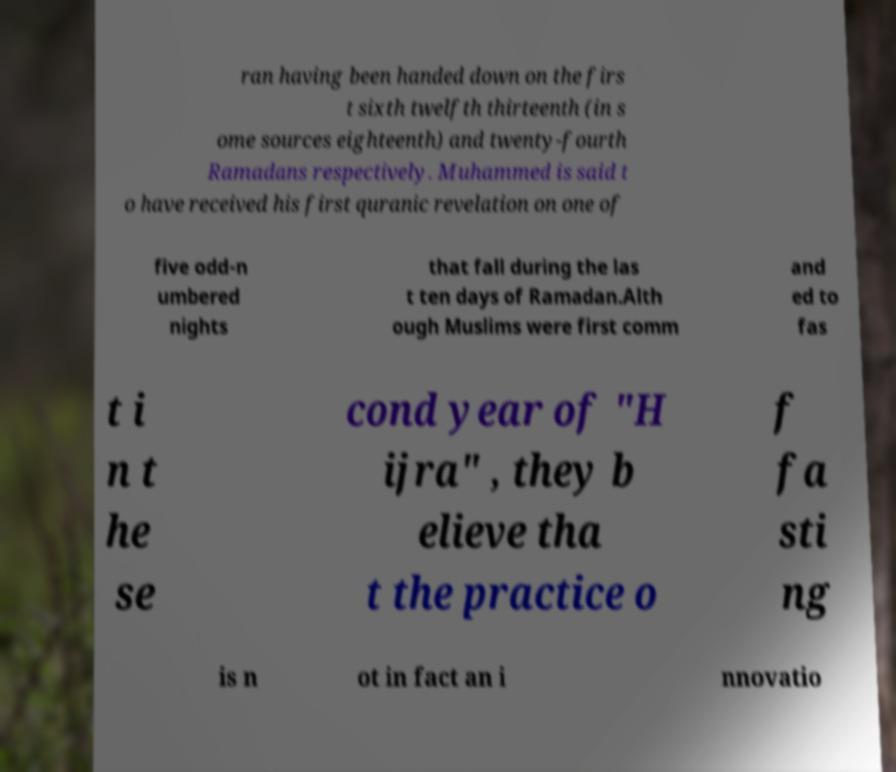What messages or text are displayed in this image? I need them in a readable, typed format. ran having been handed down on the firs t sixth twelfth thirteenth (in s ome sources eighteenth) and twenty-fourth Ramadans respectively. Muhammed is said t o have received his first quranic revelation on one of five odd-n umbered nights that fall during the las t ten days of Ramadan.Alth ough Muslims were first comm and ed to fas t i n t he se cond year of "H ijra" , they b elieve tha t the practice o f fa sti ng is n ot in fact an i nnovatio 